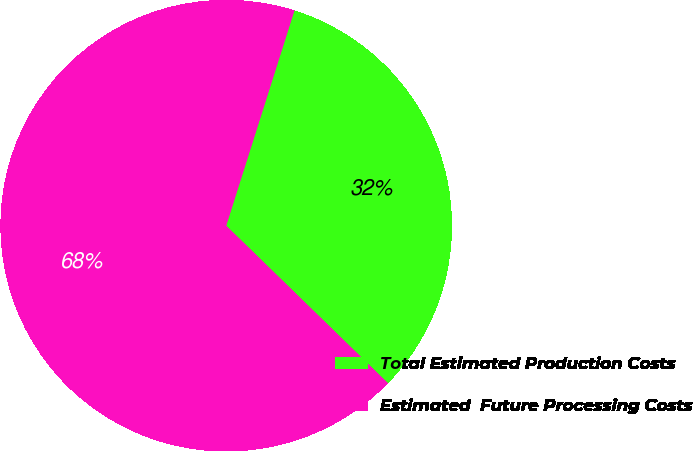<chart> <loc_0><loc_0><loc_500><loc_500><pie_chart><fcel>Total Estimated Production Costs<fcel>Estimated  Future Processing Costs<nl><fcel>32.4%<fcel>67.6%<nl></chart> 